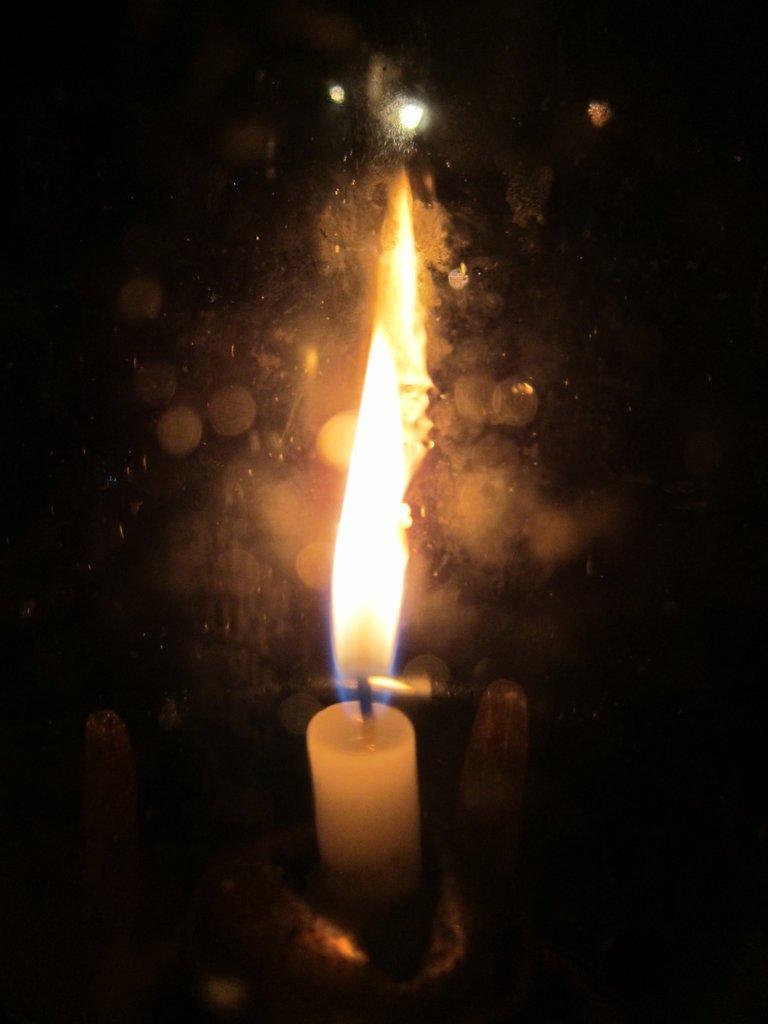Can you describe this image briefly? In this image I can see a white color candle and fire. Background is in orange and black color. 